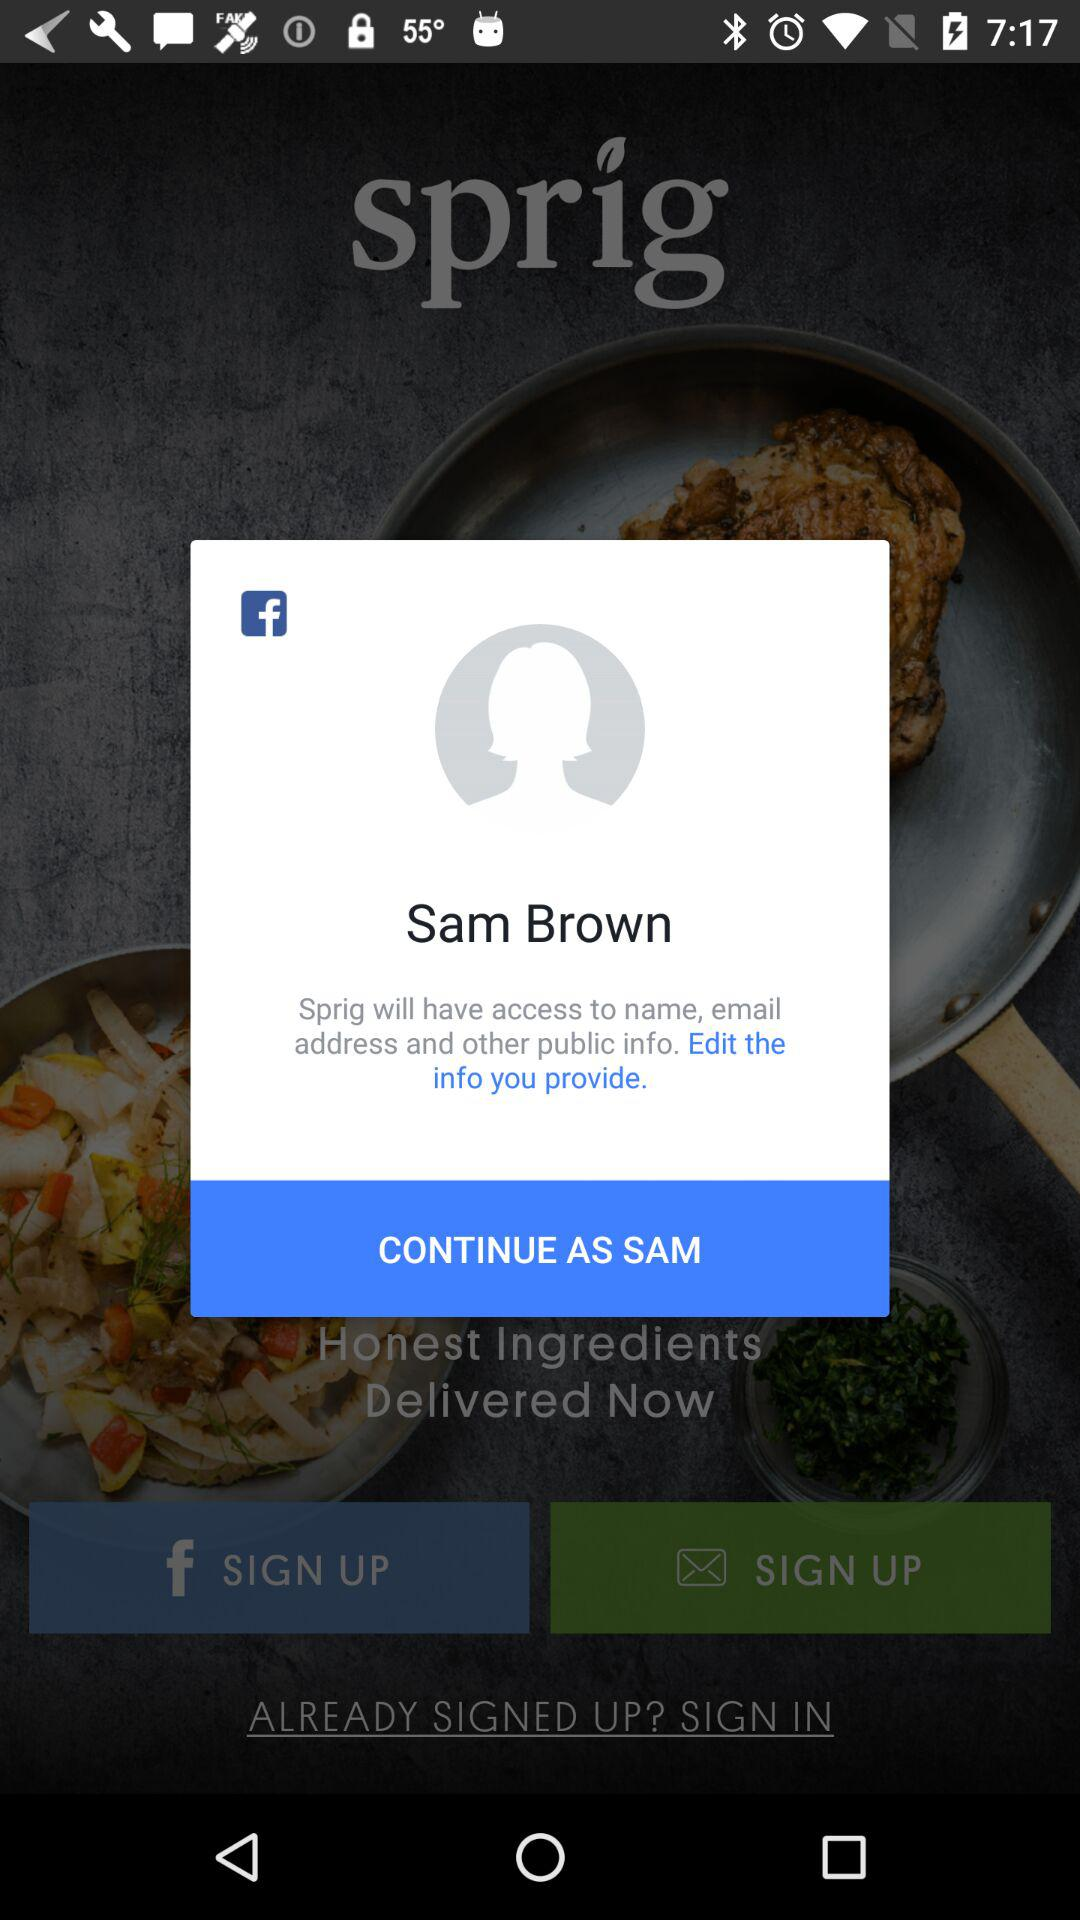Who will have access to the name and email address? The application "Sprig" will have access to the name and email address. 